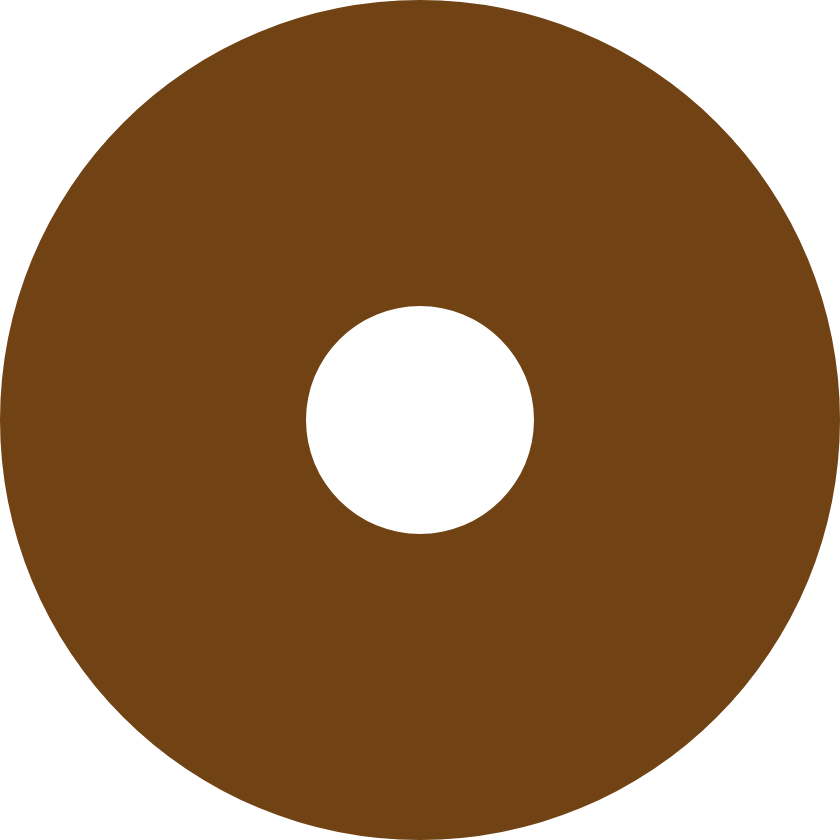Convert chart to OTSL. <chart><loc_0><loc_0><loc_500><loc_500><pie_chart><ecel><nl><fcel>100.0%<nl></chart> 